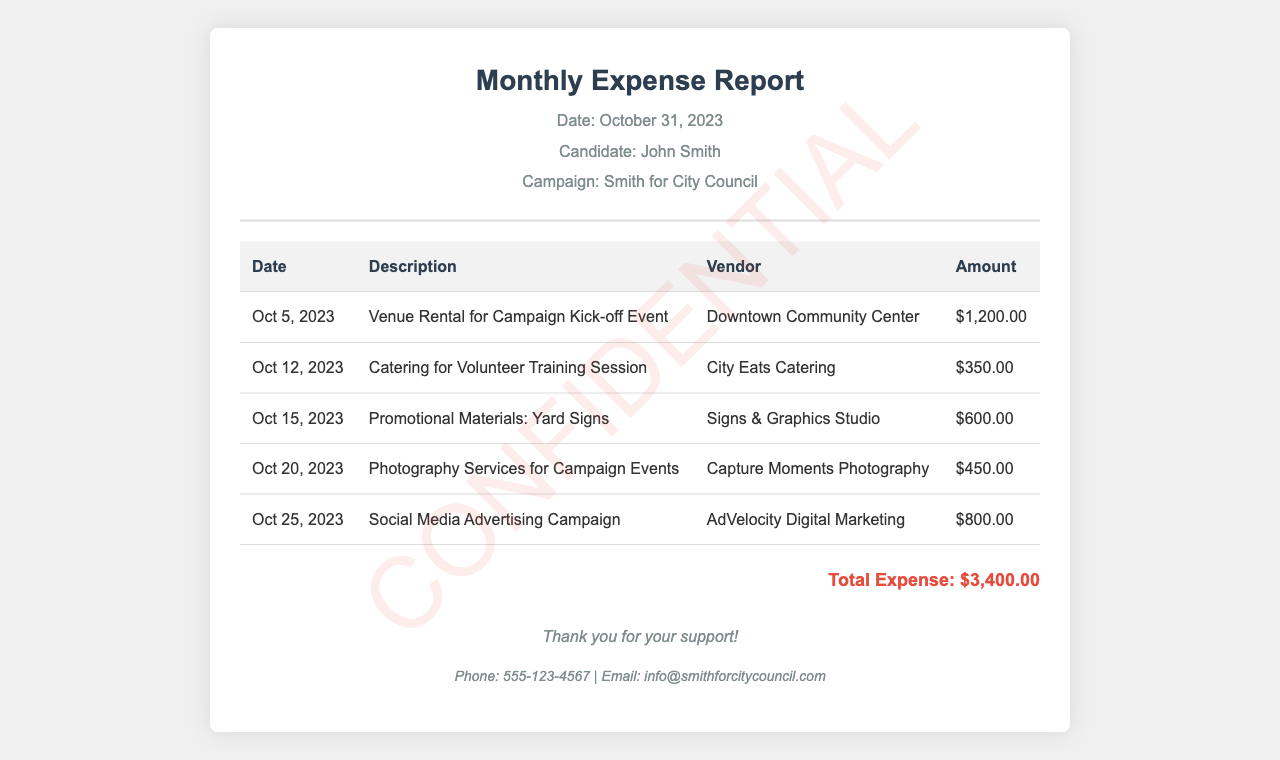What is the total expense? The total expense is indicated at the bottom of the report, which summarizes all monthly expenses.
Answer: $3,400.00 What was the vendor for the venue rental? The vendor for the venue rental is specified in the first row of the expenses table.
Answer: Downtown Community Center When was the catering service hired? The date for the catering service is found in the second row of the expenses table.
Answer: Oct 12, 2023 How much was spent on promotional materials? The amount spent on promotional materials is listed in the third row of the expenses table.
Answer: $600.00 What service was used for photography at campaign events? The service used for photography is noted in the fourth row of the expenses table.
Answer: Capture Moments Photography Which month does this expense report cover? The date indicated in the report title specifies the month of the report.
Answer: October How many events were catered in total? The number of events catered can be calculated by counting the relevant entries in the table.
Answer: 1 What type of advertising was included in the expenses? The type of advertising is found in the last entry of the expenses table.
Answer: Social Media Advertising Campaign 